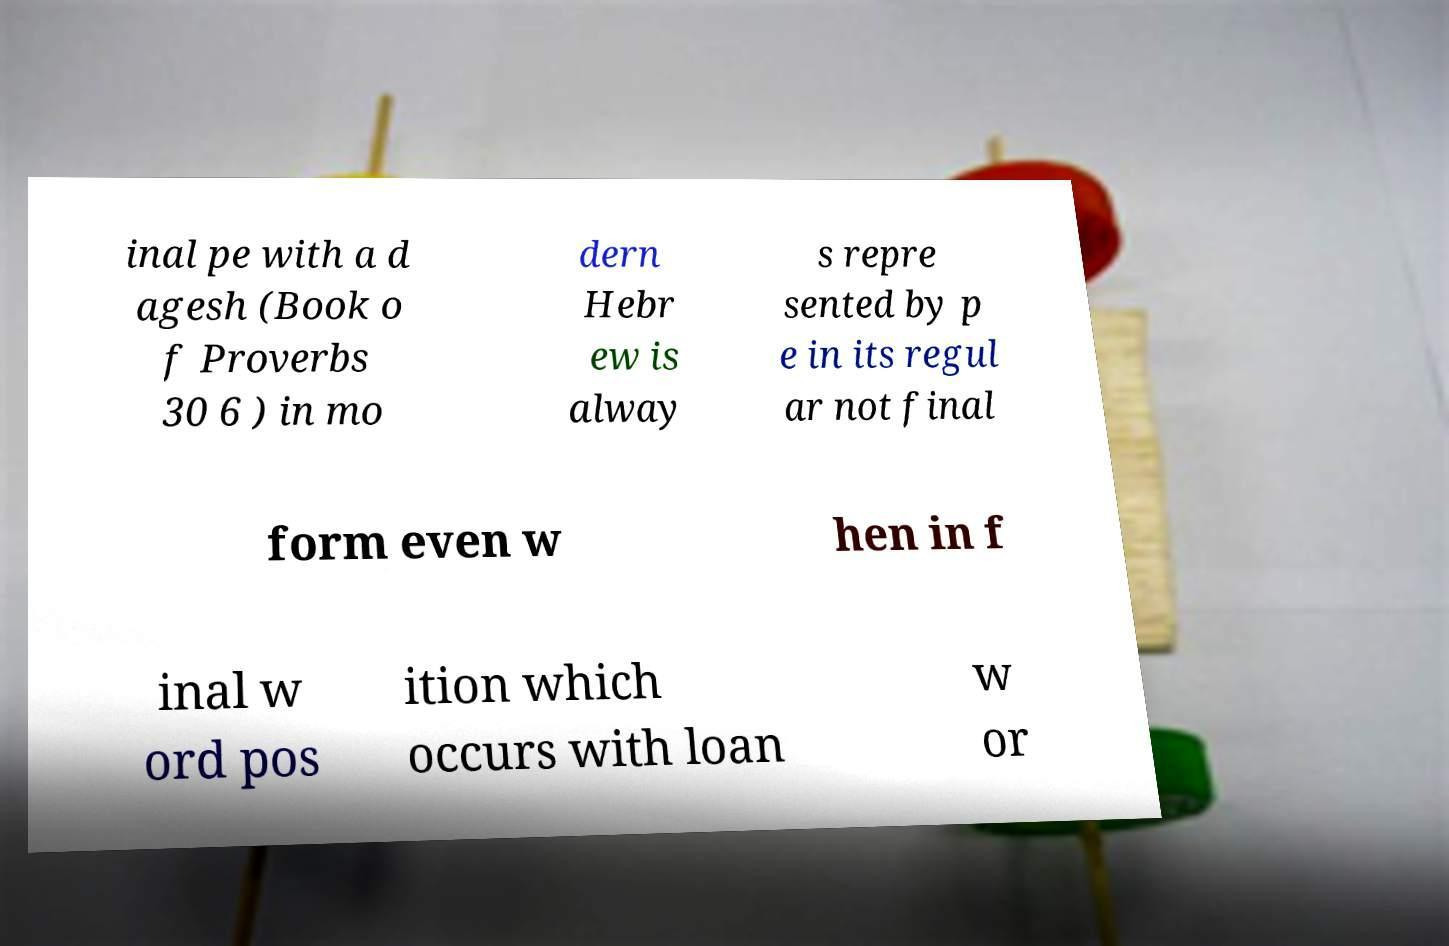For documentation purposes, I need the text within this image transcribed. Could you provide that? inal pe with a d agesh (Book o f Proverbs 30 6 ) in mo dern Hebr ew is alway s repre sented by p e in its regul ar not final form even w hen in f inal w ord pos ition which occurs with loan w or 